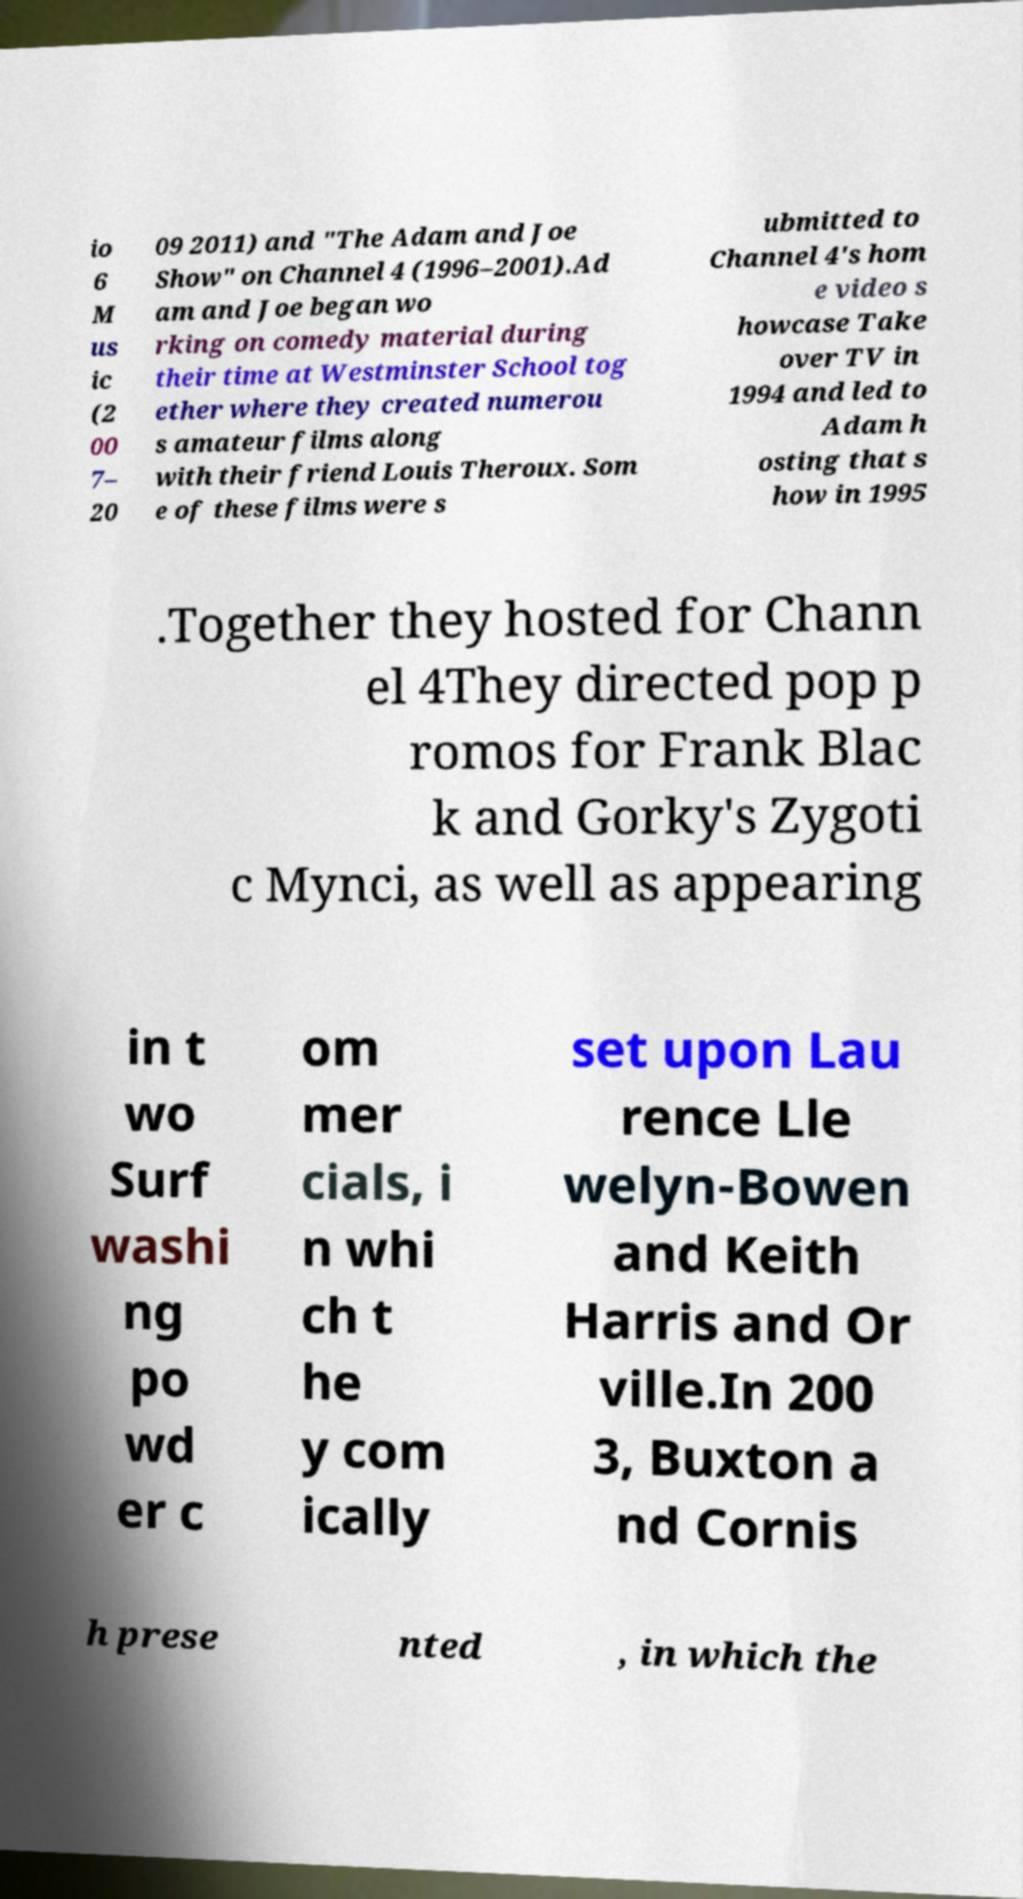I need the written content from this picture converted into text. Can you do that? io 6 M us ic (2 00 7– 20 09 2011) and "The Adam and Joe Show" on Channel 4 (1996–2001).Ad am and Joe began wo rking on comedy material during their time at Westminster School tog ether where they created numerou s amateur films along with their friend Louis Theroux. Som e of these films were s ubmitted to Channel 4's hom e video s howcase Take over TV in 1994 and led to Adam h osting that s how in 1995 .Together they hosted for Chann el 4They directed pop p romos for Frank Blac k and Gorky's Zygoti c Mynci, as well as appearing in t wo Surf washi ng po wd er c om mer cials, i n whi ch t he y com ically set upon Lau rence Lle welyn-Bowen and Keith Harris and Or ville.In 200 3, Buxton a nd Cornis h prese nted , in which the 